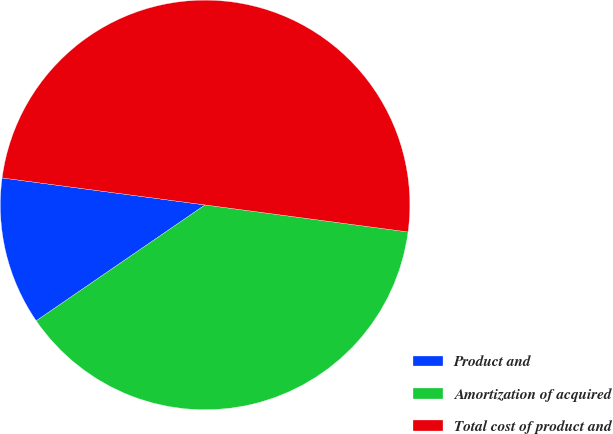Convert chart. <chart><loc_0><loc_0><loc_500><loc_500><pie_chart><fcel>Product and<fcel>Amortization of acquired<fcel>Total cost of product and<nl><fcel>11.68%<fcel>38.32%<fcel>50.0%<nl></chart> 